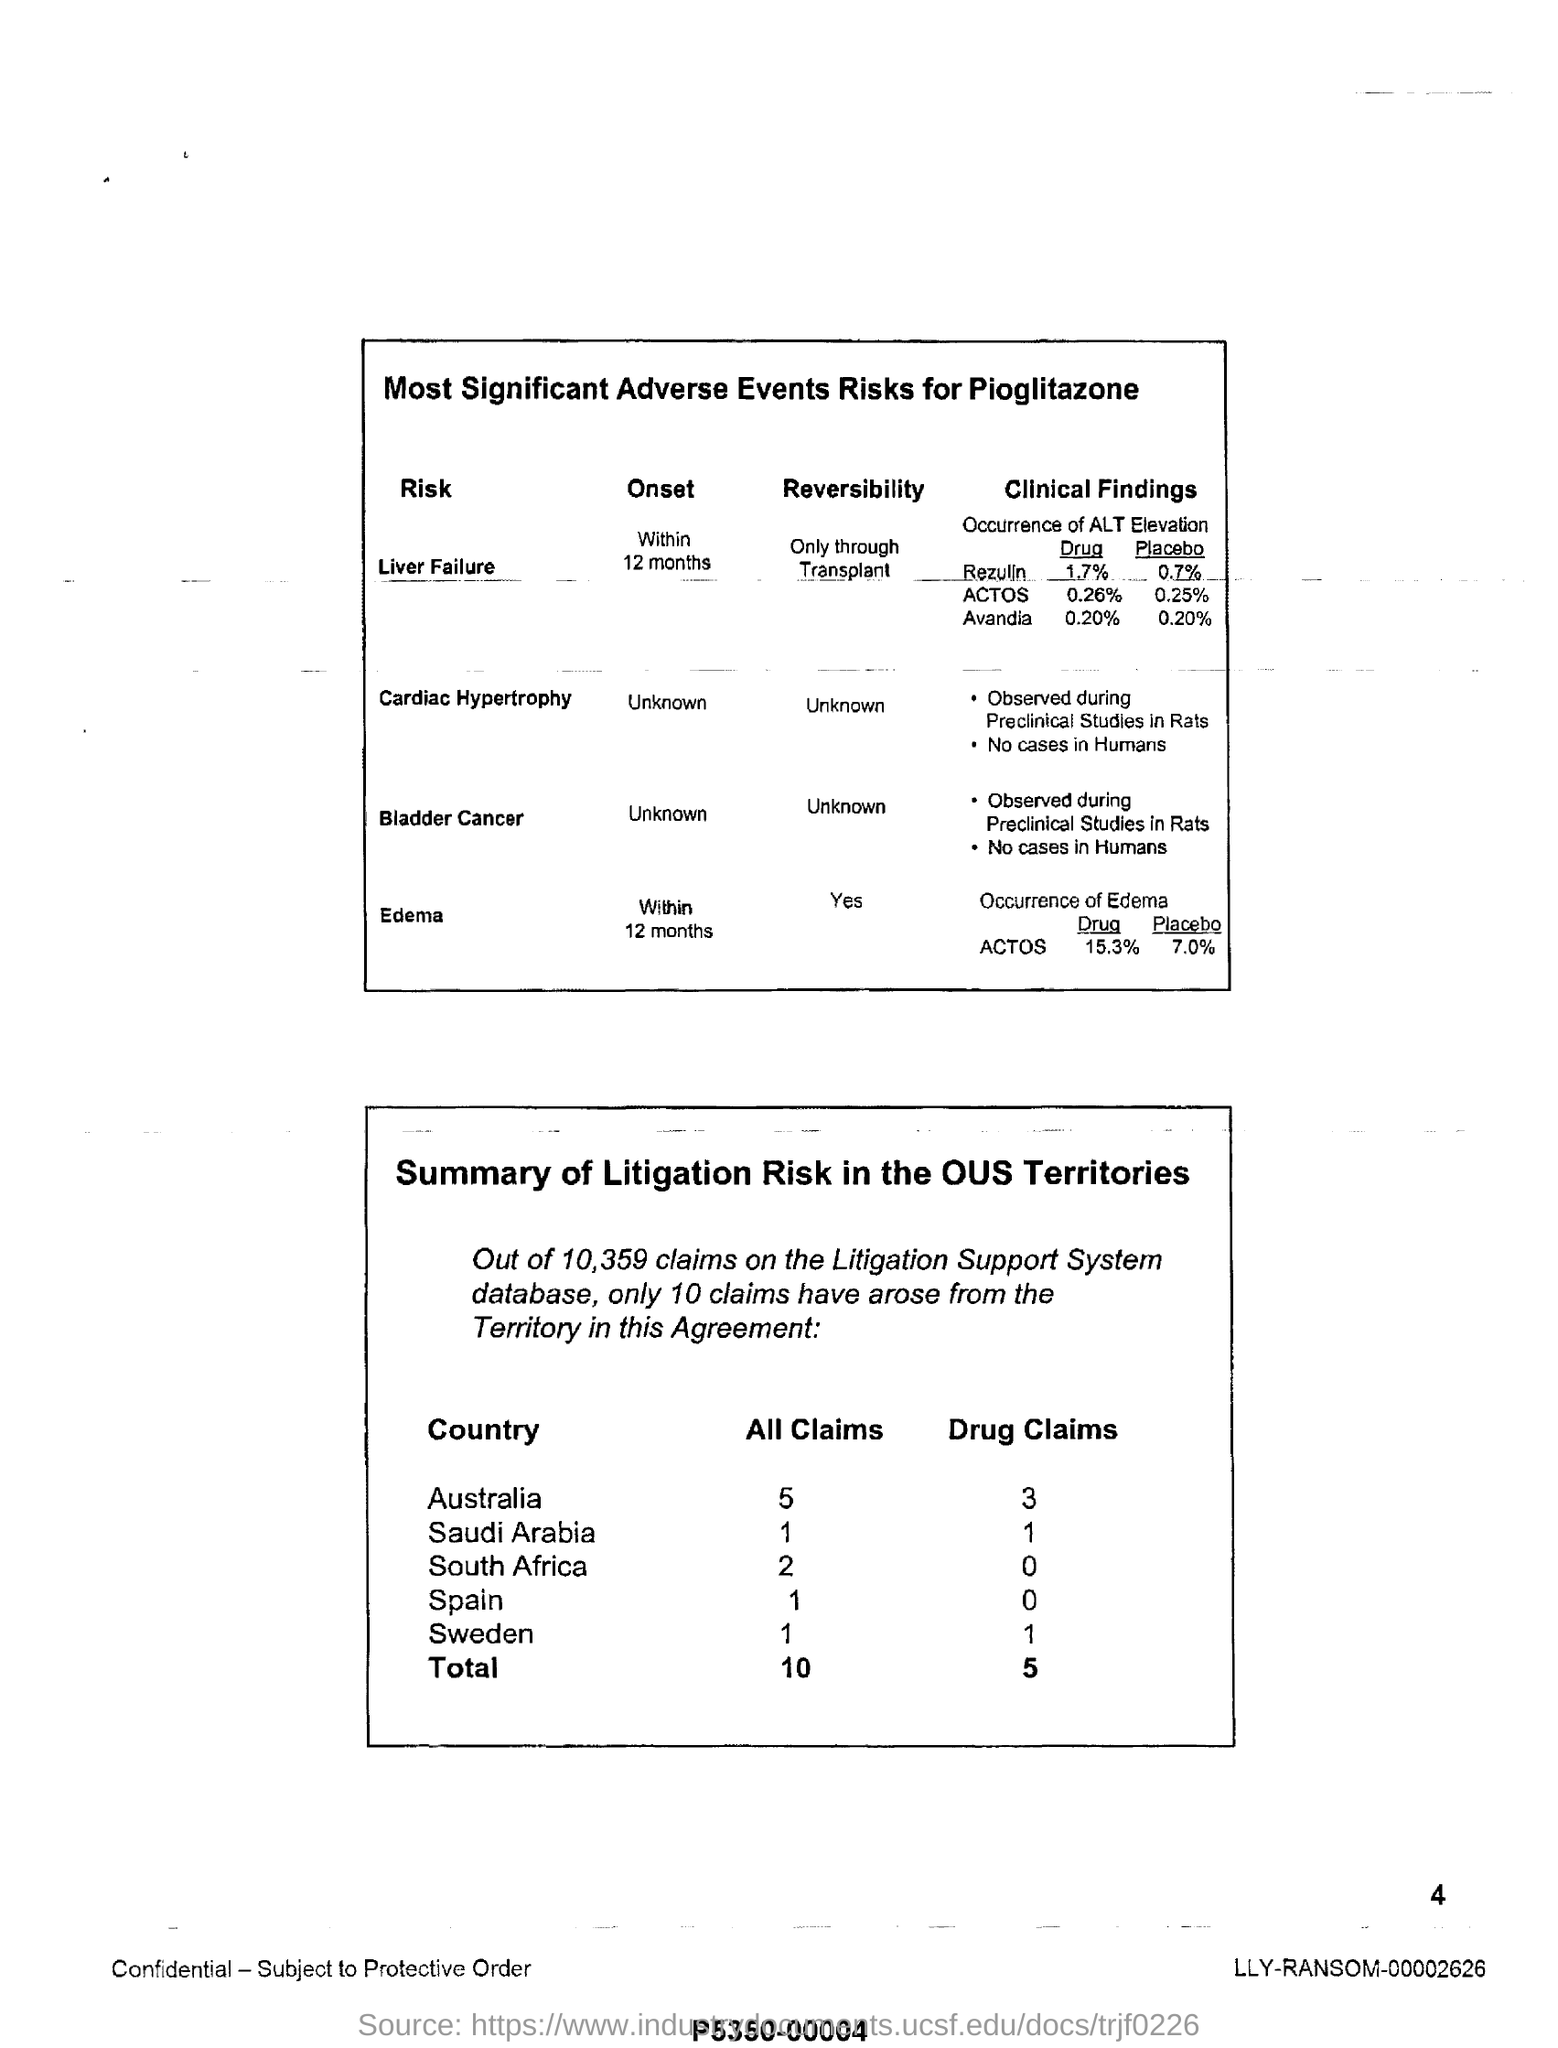Draw attention to some important aspects in this diagram. Research on bladder cancer in rats during preclinical studies revealed the first point listed in the table as the most significant clinical finding. The clinical findings showed that 0.20% of Avandia contained placebo. What is the total number of drug claims under the title of 'summary of litigation risk in the outsourced territories'? The clinical findings showed that 1.7% of the drug quantity present in Rezulin was present under the title of "clinical findings. What is the total number of all claims under the title of "summary of litigation risk in the outsourced territories"? I don't have that information. 